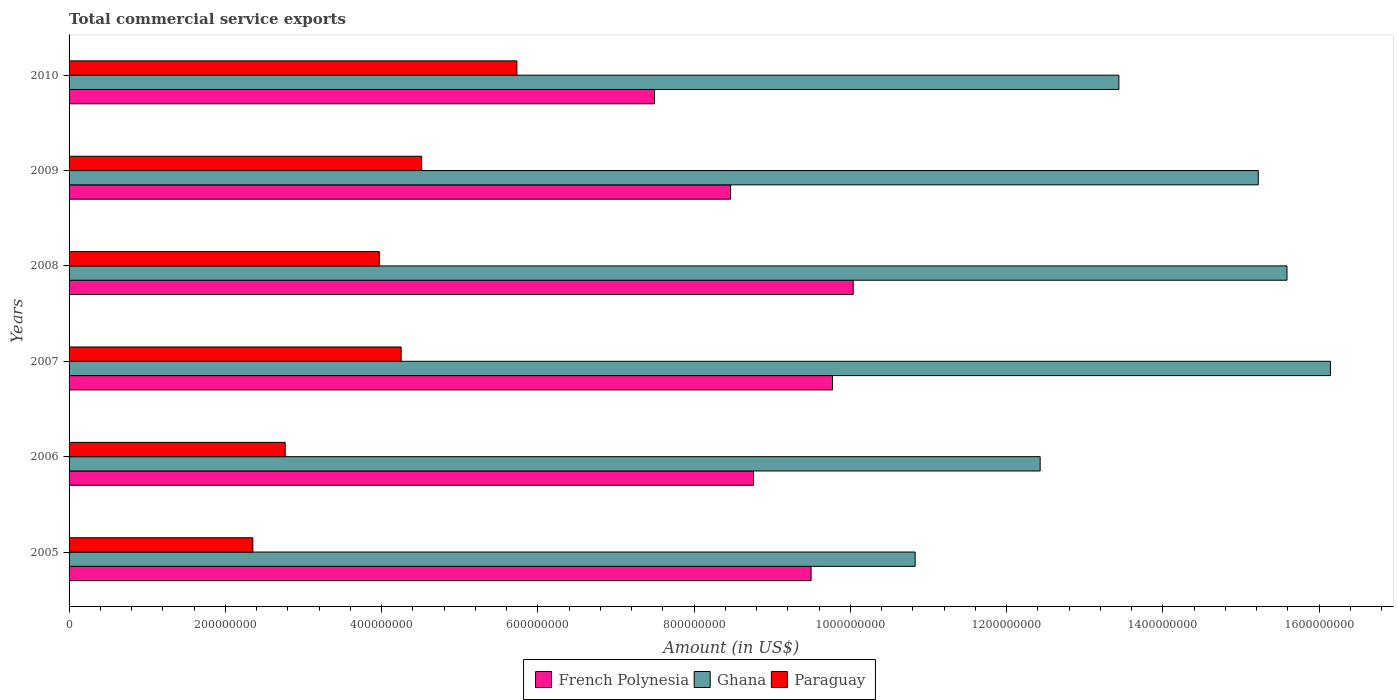How many groups of bars are there?
Provide a succinct answer. 6. How many bars are there on the 6th tick from the bottom?
Provide a succinct answer. 3. What is the label of the 6th group of bars from the top?
Your answer should be compact. 2005. In how many cases, is the number of bars for a given year not equal to the number of legend labels?
Your answer should be very brief. 0. What is the total commercial service exports in French Polynesia in 2005?
Your response must be concise. 9.50e+08. Across all years, what is the maximum total commercial service exports in Paraguay?
Your answer should be very brief. 5.73e+08. Across all years, what is the minimum total commercial service exports in Paraguay?
Give a very brief answer. 2.35e+08. In which year was the total commercial service exports in Ghana maximum?
Provide a short and direct response. 2007. In which year was the total commercial service exports in French Polynesia minimum?
Ensure brevity in your answer.  2010. What is the total total commercial service exports in Ghana in the graph?
Your answer should be very brief. 8.36e+09. What is the difference between the total commercial service exports in Ghana in 2005 and that in 2007?
Make the answer very short. -5.31e+08. What is the difference between the total commercial service exports in Paraguay in 2008 and the total commercial service exports in Ghana in 2007?
Ensure brevity in your answer.  -1.22e+09. What is the average total commercial service exports in French Polynesia per year?
Keep it short and to the point. 9.00e+08. In the year 2010, what is the difference between the total commercial service exports in Ghana and total commercial service exports in French Polynesia?
Ensure brevity in your answer.  5.94e+08. In how many years, is the total commercial service exports in French Polynesia greater than 1320000000 US$?
Your answer should be very brief. 0. What is the ratio of the total commercial service exports in Ghana in 2005 to that in 2008?
Offer a terse response. 0.69. Is the difference between the total commercial service exports in Ghana in 2006 and 2008 greater than the difference between the total commercial service exports in French Polynesia in 2006 and 2008?
Your answer should be very brief. No. What is the difference between the highest and the second highest total commercial service exports in French Polynesia?
Ensure brevity in your answer.  2.65e+07. What is the difference between the highest and the lowest total commercial service exports in Paraguay?
Your answer should be compact. 3.38e+08. Is the sum of the total commercial service exports in French Polynesia in 2007 and 2010 greater than the maximum total commercial service exports in Ghana across all years?
Your answer should be very brief. Yes. What does the 1st bar from the top in 2005 represents?
Provide a short and direct response. Paraguay. What does the 2nd bar from the bottom in 2006 represents?
Offer a terse response. Ghana. How many bars are there?
Give a very brief answer. 18. Are all the bars in the graph horizontal?
Offer a very short reply. Yes. How many years are there in the graph?
Ensure brevity in your answer.  6. What is the difference between two consecutive major ticks on the X-axis?
Your response must be concise. 2.00e+08. Are the values on the major ticks of X-axis written in scientific E-notation?
Ensure brevity in your answer.  No. Does the graph contain any zero values?
Ensure brevity in your answer.  No. How many legend labels are there?
Ensure brevity in your answer.  3. What is the title of the graph?
Your answer should be compact. Total commercial service exports. What is the label or title of the X-axis?
Provide a short and direct response. Amount (in US$). What is the Amount (in US$) in French Polynesia in 2005?
Provide a succinct answer. 9.50e+08. What is the Amount (in US$) in Ghana in 2005?
Ensure brevity in your answer.  1.08e+09. What is the Amount (in US$) in Paraguay in 2005?
Give a very brief answer. 2.35e+08. What is the Amount (in US$) in French Polynesia in 2006?
Offer a terse response. 8.76e+08. What is the Amount (in US$) in Ghana in 2006?
Your response must be concise. 1.24e+09. What is the Amount (in US$) in Paraguay in 2006?
Keep it short and to the point. 2.77e+08. What is the Amount (in US$) in French Polynesia in 2007?
Offer a terse response. 9.77e+08. What is the Amount (in US$) of Ghana in 2007?
Make the answer very short. 1.61e+09. What is the Amount (in US$) in Paraguay in 2007?
Provide a succinct answer. 4.25e+08. What is the Amount (in US$) in French Polynesia in 2008?
Provide a succinct answer. 1.00e+09. What is the Amount (in US$) in Ghana in 2008?
Provide a short and direct response. 1.56e+09. What is the Amount (in US$) of Paraguay in 2008?
Your answer should be compact. 3.97e+08. What is the Amount (in US$) of French Polynesia in 2009?
Your answer should be very brief. 8.47e+08. What is the Amount (in US$) in Ghana in 2009?
Offer a terse response. 1.52e+09. What is the Amount (in US$) of Paraguay in 2009?
Provide a succinct answer. 4.51e+08. What is the Amount (in US$) of French Polynesia in 2010?
Keep it short and to the point. 7.49e+08. What is the Amount (in US$) in Ghana in 2010?
Provide a short and direct response. 1.34e+09. What is the Amount (in US$) in Paraguay in 2010?
Your answer should be very brief. 5.73e+08. Across all years, what is the maximum Amount (in US$) in French Polynesia?
Your answer should be compact. 1.00e+09. Across all years, what is the maximum Amount (in US$) in Ghana?
Ensure brevity in your answer.  1.61e+09. Across all years, what is the maximum Amount (in US$) in Paraguay?
Offer a very short reply. 5.73e+08. Across all years, what is the minimum Amount (in US$) of French Polynesia?
Your response must be concise. 7.49e+08. Across all years, what is the minimum Amount (in US$) of Ghana?
Offer a terse response. 1.08e+09. Across all years, what is the minimum Amount (in US$) in Paraguay?
Keep it short and to the point. 2.35e+08. What is the total Amount (in US$) in French Polynesia in the graph?
Keep it short and to the point. 5.40e+09. What is the total Amount (in US$) in Ghana in the graph?
Provide a succinct answer. 8.36e+09. What is the total Amount (in US$) of Paraguay in the graph?
Your answer should be compact. 2.36e+09. What is the difference between the Amount (in US$) of French Polynesia in 2005 and that in 2006?
Your answer should be very brief. 7.36e+07. What is the difference between the Amount (in US$) of Ghana in 2005 and that in 2006?
Provide a succinct answer. -1.60e+08. What is the difference between the Amount (in US$) of Paraguay in 2005 and that in 2006?
Your response must be concise. -4.14e+07. What is the difference between the Amount (in US$) of French Polynesia in 2005 and that in 2007?
Offer a very short reply. -2.74e+07. What is the difference between the Amount (in US$) of Ghana in 2005 and that in 2007?
Your response must be concise. -5.31e+08. What is the difference between the Amount (in US$) of Paraguay in 2005 and that in 2007?
Make the answer very short. -1.90e+08. What is the difference between the Amount (in US$) in French Polynesia in 2005 and that in 2008?
Give a very brief answer. -5.39e+07. What is the difference between the Amount (in US$) in Ghana in 2005 and that in 2008?
Make the answer very short. -4.76e+08. What is the difference between the Amount (in US$) of Paraguay in 2005 and that in 2008?
Offer a terse response. -1.62e+08. What is the difference between the Amount (in US$) of French Polynesia in 2005 and that in 2009?
Provide a short and direct response. 1.03e+08. What is the difference between the Amount (in US$) of Ghana in 2005 and that in 2009?
Your answer should be very brief. -4.39e+08. What is the difference between the Amount (in US$) of Paraguay in 2005 and that in 2009?
Provide a succinct answer. -2.16e+08. What is the difference between the Amount (in US$) of French Polynesia in 2005 and that in 2010?
Provide a succinct answer. 2.00e+08. What is the difference between the Amount (in US$) in Ghana in 2005 and that in 2010?
Your answer should be very brief. -2.61e+08. What is the difference between the Amount (in US$) of Paraguay in 2005 and that in 2010?
Your answer should be very brief. -3.38e+08. What is the difference between the Amount (in US$) of French Polynesia in 2006 and that in 2007?
Your answer should be very brief. -1.01e+08. What is the difference between the Amount (in US$) in Ghana in 2006 and that in 2007?
Your answer should be very brief. -3.71e+08. What is the difference between the Amount (in US$) in Paraguay in 2006 and that in 2007?
Make the answer very short. -1.48e+08. What is the difference between the Amount (in US$) in French Polynesia in 2006 and that in 2008?
Provide a short and direct response. -1.28e+08. What is the difference between the Amount (in US$) of Ghana in 2006 and that in 2008?
Provide a short and direct response. -3.16e+08. What is the difference between the Amount (in US$) of Paraguay in 2006 and that in 2008?
Your answer should be compact. -1.20e+08. What is the difference between the Amount (in US$) in French Polynesia in 2006 and that in 2009?
Provide a succinct answer. 2.93e+07. What is the difference between the Amount (in US$) in Ghana in 2006 and that in 2009?
Provide a short and direct response. -2.79e+08. What is the difference between the Amount (in US$) in Paraguay in 2006 and that in 2009?
Offer a very short reply. -1.75e+08. What is the difference between the Amount (in US$) of French Polynesia in 2006 and that in 2010?
Your response must be concise. 1.27e+08. What is the difference between the Amount (in US$) of Ghana in 2006 and that in 2010?
Provide a short and direct response. -1.01e+08. What is the difference between the Amount (in US$) in Paraguay in 2006 and that in 2010?
Provide a succinct answer. -2.97e+08. What is the difference between the Amount (in US$) of French Polynesia in 2007 and that in 2008?
Your response must be concise. -2.65e+07. What is the difference between the Amount (in US$) of Ghana in 2007 and that in 2008?
Provide a succinct answer. 5.56e+07. What is the difference between the Amount (in US$) in Paraguay in 2007 and that in 2008?
Keep it short and to the point. 2.80e+07. What is the difference between the Amount (in US$) of French Polynesia in 2007 and that in 2009?
Keep it short and to the point. 1.30e+08. What is the difference between the Amount (in US$) of Ghana in 2007 and that in 2009?
Your answer should be compact. 9.24e+07. What is the difference between the Amount (in US$) of Paraguay in 2007 and that in 2009?
Keep it short and to the point. -2.63e+07. What is the difference between the Amount (in US$) in French Polynesia in 2007 and that in 2010?
Make the answer very short. 2.28e+08. What is the difference between the Amount (in US$) in Ghana in 2007 and that in 2010?
Provide a succinct answer. 2.71e+08. What is the difference between the Amount (in US$) of Paraguay in 2007 and that in 2010?
Give a very brief answer. -1.48e+08. What is the difference between the Amount (in US$) in French Polynesia in 2008 and that in 2009?
Keep it short and to the point. 1.57e+08. What is the difference between the Amount (in US$) of Ghana in 2008 and that in 2009?
Keep it short and to the point. 3.67e+07. What is the difference between the Amount (in US$) in Paraguay in 2008 and that in 2009?
Provide a short and direct response. -5.42e+07. What is the difference between the Amount (in US$) of French Polynesia in 2008 and that in 2010?
Provide a succinct answer. 2.54e+08. What is the difference between the Amount (in US$) in Ghana in 2008 and that in 2010?
Your answer should be compact. 2.15e+08. What is the difference between the Amount (in US$) of Paraguay in 2008 and that in 2010?
Offer a very short reply. -1.76e+08. What is the difference between the Amount (in US$) in French Polynesia in 2009 and that in 2010?
Your response must be concise. 9.74e+07. What is the difference between the Amount (in US$) of Ghana in 2009 and that in 2010?
Your answer should be compact. 1.78e+08. What is the difference between the Amount (in US$) in Paraguay in 2009 and that in 2010?
Ensure brevity in your answer.  -1.22e+08. What is the difference between the Amount (in US$) of French Polynesia in 2005 and the Amount (in US$) of Ghana in 2006?
Your response must be concise. -2.93e+08. What is the difference between the Amount (in US$) in French Polynesia in 2005 and the Amount (in US$) in Paraguay in 2006?
Ensure brevity in your answer.  6.73e+08. What is the difference between the Amount (in US$) in Ghana in 2005 and the Amount (in US$) in Paraguay in 2006?
Your answer should be very brief. 8.06e+08. What is the difference between the Amount (in US$) of French Polynesia in 2005 and the Amount (in US$) of Ghana in 2007?
Provide a succinct answer. -6.65e+08. What is the difference between the Amount (in US$) of French Polynesia in 2005 and the Amount (in US$) of Paraguay in 2007?
Offer a very short reply. 5.25e+08. What is the difference between the Amount (in US$) in Ghana in 2005 and the Amount (in US$) in Paraguay in 2007?
Your response must be concise. 6.58e+08. What is the difference between the Amount (in US$) in French Polynesia in 2005 and the Amount (in US$) in Ghana in 2008?
Offer a terse response. -6.09e+08. What is the difference between the Amount (in US$) in French Polynesia in 2005 and the Amount (in US$) in Paraguay in 2008?
Make the answer very short. 5.53e+08. What is the difference between the Amount (in US$) in Ghana in 2005 and the Amount (in US$) in Paraguay in 2008?
Your answer should be compact. 6.86e+08. What is the difference between the Amount (in US$) of French Polynesia in 2005 and the Amount (in US$) of Ghana in 2009?
Make the answer very short. -5.72e+08. What is the difference between the Amount (in US$) in French Polynesia in 2005 and the Amount (in US$) in Paraguay in 2009?
Your response must be concise. 4.98e+08. What is the difference between the Amount (in US$) of Ghana in 2005 and the Amount (in US$) of Paraguay in 2009?
Keep it short and to the point. 6.32e+08. What is the difference between the Amount (in US$) of French Polynesia in 2005 and the Amount (in US$) of Ghana in 2010?
Your answer should be compact. -3.94e+08. What is the difference between the Amount (in US$) in French Polynesia in 2005 and the Amount (in US$) in Paraguay in 2010?
Provide a succinct answer. 3.77e+08. What is the difference between the Amount (in US$) in Ghana in 2005 and the Amount (in US$) in Paraguay in 2010?
Your answer should be compact. 5.10e+08. What is the difference between the Amount (in US$) of French Polynesia in 2006 and the Amount (in US$) of Ghana in 2007?
Your response must be concise. -7.38e+08. What is the difference between the Amount (in US$) in French Polynesia in 2006 and the Amount (in US$) in Paraguay in 2007?
Give a very brief answer. 4.51e+08. What is the difference between the Amount (in US$) of Ghana in 2006 and the Amount (in US$) of Paraguay in 2007?
Your answer should be compact. 8.18e+08. What is the difference between the Amount (in US$) of French Polynesia in 2006 and the Amount (in US$) of Ghana in 2008?
Offer a terse response. -6.83e+08. What is the difference between the Amount (in US$) of French Polynesia in 2006 and the Amount (in US$) of Paraguay in 2008?
Offer a terse response. 4.79e+08. What is the difference between the Amount (in US$) in Ghana in 2006 and the Amount (in US$) in Paraguay in 2008?
Offer a very short reply. 8.46e+08. What is the difference between the Amount (in US$) of French Polynesia in 2006 and the Amount (in US$) of Ghana in 2009?
Your answer should be compact. -6.46e+08. What is the difference between the Amount (in US$) of French Polynesia in 2006 and the Amount (in US$) of Paraguay in 2009?
Your response must be concise. 4.25e+08. What is the difference between the Amount (in US$) of Ghana in 2006 and the Amount (in US$) of Paraguay in 2009?
Make the answer very short. 7.92e+08. What is the difference between the Amount (in US$) of French Polynesia in 2006 and the Amount (in US$) of Ghana in 2010?
Your response must be concise. -4.68e+08. What is the difference between the Amount (in US$) in French Polynesia in 2006 and the Amount (in US$) in Paraguay in 2010?
Your response must be concise. 3.03e+08. What is the difference between the Amount (in US$) in Ghana in 2006 and the Amount (in US$) in Paraguay in 2010?
Offer a very short reply. 6.70e+08. What is the difference between the Amount (in US$) in French Polynesia in 2007 and the Amount (in US$) in Ghana in 2008?
Make the answer very short. -5.82e+08. What is the difference between the Amount (in US$) in French Polynesia in 2007 and the Amount (in US$) in Paraguay in 2008?
Ensure brevity in your answer.  5.80e+08. What is the difference between the Amount (in US$) in Ghana in 2007 and the Amount (in US$) in Paraguay in 2008?
Your answer should be compact. 1.22e+09. What is the difference between the Amount (in US$) in French Polynesia in 2007 and the Amount (in US$) in Ghana in 2009?
Your response must be concise. -5.45e+08. What is the difference between the Amount (in US$) in French Polynesia in 2007 and the Amount (in US$) in Paraguay in 2009?
Keep it short and to the point. 5.26e+08. What is the difference between the Amount (in US$) of Ghana in 2007 and the Amount (in US$) of Paraguay in 2009?
Provide a succinct answer. 1.16e+09. What is the difference between the Amount (in US$) of French Polynesia in 2007 and the Amount (in US$) of Ghana in 2010?
Give a very brief answer. -3.67e+08. What is the difference between the Amount (in US$) in French Polynesia in 2007 and the Amount (in US$) in Paraguay in 2010?
Your answer should be very brief. 4.04e+08. What is the difference between the Amount (in US$) in Ghana in 2007 and the Amount (in US$) in Paraguay in 2010?
Provide a short and direct response. 1.04e+09. What is the difference between the Amount (in US$) in French Polynesia in 2008 and the Amount (in US$) in Ghana in 2009?
Offer a very short reply. -5.18e+08. What is the difference between the Amount (in US$) in French Polynesia in 2008 and the Amount (in US$) in Paraguay in 2009?
Your response must be concise. 5.52e+08. What is the difference between the Amount (in US$) in Ghana in 2008 and the Amount (in US$) in Paraguay in 2009?
Make the answer very short. 1.11e+09. What is the difference between the Amount (in US$) of French Polynesia in 2008 and the Amount (in US$) of Ghana in 2010?
Your answer should be compact. -3.40e+08. What is the difference between the Amount (in US$) of French Polynesia in 2008 and the Amount (in US$) of Paraguay in 2010?
Ensure brevity in your answer.  4.30e+08. What is the difference between the Amount (in US$) of Ghana in 2008 and the Amount (in US$) of Paraguay in 2010?
Give a very brief answer. 9.86e+08. What is the difference between the Amount (in US$) of French Polynesia in 2009 and the Amount (in US$) of Ghana in 2010?
Give a very brief answer. -4.97e+08. What is the difference between the Amount (in US$) in French Polynesia in 2009 and the Amount (in US$) in Paraguay in 2010?
Your response must be concise. 2.74e+08. What is the difference between the Amount (in US$) of Ghana in 2009 and the Amount (in US$) of Paraguay in 2010?
Make the answer very short. 9.49e+08. What is the average Amount (in US$) in French Polynesia per year?
Your response must be concise. 9.00e+08. What is the average Amount (in US$) in Ghana per year?
Offer a terse response. 1.39e+09. What is the average Amount (in US$) in Paraguay per year?
Your answer should be very brief. 3.93e+08. In the year 2005, what is the difference between the Amount (in US$) of French Polynesia and Amount (in US$) of Ghana?
Provide a succinct answer. -1.33e+08. In the year 2005, what is the difference between the Amount (in US$) in French Polynesia and Amount (in US$) in Paraguay?
Offer a very short reply. 7.14e+08. In the year 2005, what is the difference between the Amount (in US$) in Ghana and Amount (in US$) in Paraguay?
Offer a very short reply. 8.48e+08. In the year 2006, what is the difference between the Amount (in US$) of French Polynesia and Amount (in US$) of Ghana?
Keep it short and to the point. -3.67e+08. In the year 2006, what is the difference between the Amount (in US$) in French Polynesia and Amount (in US$) in Paraguay?
Your answer should be compact. 5.99e+08. In the year 2006, what is the difference between the Amount (in US$) in Ghana and Amount (in US$) in Paraguay?
Keep it short and to the point. 9.66e+08. In the year 2007, what is the difference between the Amount (in US$) in French Polynesia and Amount (in US$) in Ghana?
Provide a short and direct response. -6.37e+08. In the year 2007, what is the difference between the Amount (in US$) of French Polynesia and Amount (in US$) of Paraguay?
Your answer should be very brief. 5.52e+08. In the year 2007, what is the difference between the Amount (in US$) in Ghana and Amount (in US$) in Paraguay?
Provide a succinct answer. 1.19e+09. In the year 2008, what is the difference between the Amount (in US$) in French Polynesia and Amount (in US$) in Ghana?
Offer a very short reply. -5.55e+08. In the year 2008, what is the difference between the Amount (in US$) in French Polynesia and Amount (in US$) in Paraguay?
Give a very brief answer. 6.07e+08. In the year 2008, what is the difference between the Amount (in US$) of Ghana and Amount (in US$) of Paraguay?
Ensure brevity in your answer.  1.16e+09. In the year 2009, what is the difference between the Amount (in US$) in French Polynesia and Amount (in US$) in Ghana?
Give a very brief answer. -6.75e+08. In the year 2009, what is the difference between the Amount (in US$) in French Polynesia and Amount (in US$) in Paraguay?
Your response must be concise. 3.95e+08. In the year 2009, what is the difference between the Amount (in US$) in Ghana and Amount (in US$) in Paraguay?
Give a very brief answer. 1.07e+09. In the year 2010, what is the difference between the Amount (in US$) of French Polynesia and Amount (in US$) of Ghana?
Your answer should be very brief. -5.94e+08. In the year 2010, what is the difference between the Amount (in US$) in French Polynesia and Amount (in US$) in Paraguay?
Provide a succinct answer. 1.76e+08. In the year 2010, what is the difference between the Amount (in US$) of Ghana and Amount (in US$) of Paraguay?
Offer a very short reply. 7.70e+08. What is the ratio of the Amount (in US$) in French Polynesia in 2005 to that in 2006?
Offer a very short reply. 1.08. What is the ratio of the Amount (in US$) of Ghana in 2005 to that in 2006?
Your answer should be very brief. 0.87. What is the ratio of the Amount (in US$) in Paraguay in 2005 to that in 2006?
Provide a succinct answer. 0.85. What is the ratio of the Amount (in US$) in French Polynesia in 2005 to that in 2007?
Keep it short and to the point. 0.97. What is the ratio of the Amount (in US$) in Ghana in 2005 to that in 2007?
Keep it short and to the point. 0.67. What is the ratio of the Amount (in US$) in Paraguay in 2005 to that in 2007?
Give a very brief answer. 0.55. What is the ratio of the Amount (in US$) of French Polynesia in 2005 to that in 2008?
Make the answer very short. 0.95. What is the ratio of the Amount (in US$) in Ghana in 2005 to that in 2008?
Ensure brevity in your answer.  0.69. What is the ratio of the Amount (in US$) of Paraguay in 2005 to that in 2008?
Ensure brevity in your answer.  0.59. What is the ratio of the Amount (in US$) in French Polynesia in 2005 to that in 2009?
Provide a short and direct response. 1.12. What is the ratio of the Amount (in US$) in Ghana in 2005 to that in 2009?
Provide a short and direct response. 0.71. What is the ratio of the Amount (in US$) of Paraguay in 2005 to that in 2009?
Provide a succinct answer. 0.52. What is the ratio of the Amount (in US$) in French Polynesia in 2005 to that in 2010?
Make the answer very short. 1.27. What is the ratio of the Amount (in US$) of Ghana in 2005 to that in 2010?
Your response must be concise. 0.81. What is the ratio of the Amount (in US$) of Paraguay in 2005 to that in 2010?
Your response must be concise. 0.41. What is the ratio of the Amount (in US$) of French Polynesia in 2006 to that in 2007?
Offer a terse response. 0.9. What is the ratio of the Amount (in US$) in Ghana in 2006 to that in 2007?
Offer a very short reply. 0.77. What is the ratio of the Amount (in US$) of Paraguay in 2006 to that in 2007?
Your answer should be very brief. 0.65. What is the ratio of the Amount (in US$) of French Polynesia in 2006 to that in 2008?
Make the answer very short. 0.87. What is the ratio of the Amount (in US$) in Ghana in 2006 to that in 2008?
Give a very brief answer. 0.8. What is the ratio of the Amount (in US$) in Paraguay in 2006 to that in 2008?
Your answer should be compact. 0.7. What is the ratio of the Amount (in US$) of French Polynesia in 2006 to that in 2009?
Your answer should be very brief. 1.03. What is the ratio of the Amount (in US$) of Ghana in 2006 to that in 2009?
Your answer should be very brief. 0.82. What is the ratio of the Amount (in US$) in Paraguay in 2006 to that in 2009?
Offer a very short reply. 0.61. What is the ratio of the Amount (in US$) of French Polynesia in 2006 to that in 2010?
Your response must be concise. 1.17. What is the ratio of the Amount (in US$) in Ghana in 2006 to that in 2010?
Give a very brief answer. 0.93. What is the ratio of the Amount (in US$) of Paraguay in 2006 to that in 2010?
Keep it short and to the point. 0.48. What is the ratio of the Amount (in US$) of French Polynesia in 2007 to that in 2008?
Ensure brevity in your answer.  0.97. What is the ratio of the Amount (in US$) of Ghana in 2007 to that in 2008?
Keep it short and to the point. 1.04. What is the ratio of the Amount (in US$) of Paraguay in 2007 to that in 2008?
Give a very brief answer. 1.07. What is the ratio of the Amount (in US$) of French Polynesia in 2007 to that in 2009?
Make the answer very short. 1.15. What is the ratio of the Amount (in US$) of Ghana in 2007 to that in 2009?
Provide a short and direct response. 1.06. What is the ratio of the Amount (in US$) of Paraguay in 2007 to that in 2009?
Make the answer very short. 0.94. What is the ratio of the Amount (in US$) of French Polynesia in 2007 to that in 2010?
Your answer should be compact. 1.3. What is the ratio of the Amount (in US$) of Ghana in 2007 to that in 2010?
Provide a succinct answer. 1.2. What is the ratio of the Amount (in US$) of Paraguay in 2007 to that in 2010?
Provide a succinct answer. 0.74. What is the ratio of the Amount (in US$) of French Polynesia in 2008 to that in 2009?
Your response must be concise. 1.19. What is the ratio of the Amount (in US$) of Ghana in 2008 to that in 2009?
Offer a very short reply. 1.02. What is the ratio of the Amount (in US$) of Paraguay in 2008 to that in 2009?
Make the answer very short. 0.88. What is the ratio of the Amount (in US$) in French Polynesia in 2008 to that in 2010?
Offer a terse response. 1.34. What is the ratio of the Amount (in US$) of Ghana in 2008 to that in 2010?
Give a very brief answer. 1.16. What is the ratio of the Amount (in US$) of Paraguay in 2008 to that in 2010?
Offer a terse response. 0.69. What is the ratio of the Amount (in US$) in French Polynesia in 2009 to that in 2010?
Provide a succinct answer. 1.13. What is the ratio of the Amount (in US$) of Ghana in 2009 to that in 2010?
Your response must be concise. 1.13. What is the ratio of the Amount (in US$) in Paraguay in 2009 to that in 2010?
Your response must be concise. 0.79. What is the difference between the highest and the second highest Amount (in US$) of French Polynesia?
Provide a short and direct response. 2.65e+07. What is the difference between the highest and the second highest Amount (in US$) of Ghana?
Your response must be concise. 5.56e+07. What is the difference between the highest and the second highest Amount (in US$) of Paraguay?
Your response must be concise. 1.22e+08. What is the difference between the highest and the lowest Amount (in US$) in French Polynesia?
Keep it short and to the point. 2.54e+08. What is the difference between the highest and the lowest Amount (in US$) of Ghana?
Ensure brevity in your answer.  5.31e+08. What is the difference between the highest and the lowest Amount (in US$) in Paraguay?
Your answer should be compact. 3.38e+08. 